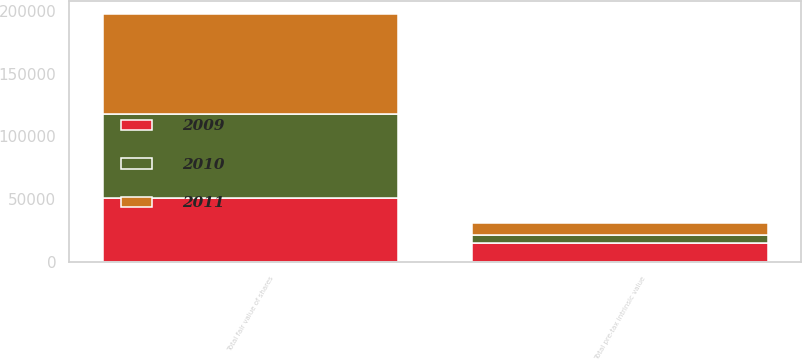Convert chart. <chart><loc_0><loc_0><loc_500><loc_500><stacked_bar_chart><ecel><fcel>Total pre-tax intrinsic value<fcel>Total fair value of shares<nl><fcel>2010<fcel>6429<fcel>67076<nl><fcel>2011<fcel>9567<fcel>79434<nl><fcel>2009<fcel>15533<fcel>51013<nl></chart> 